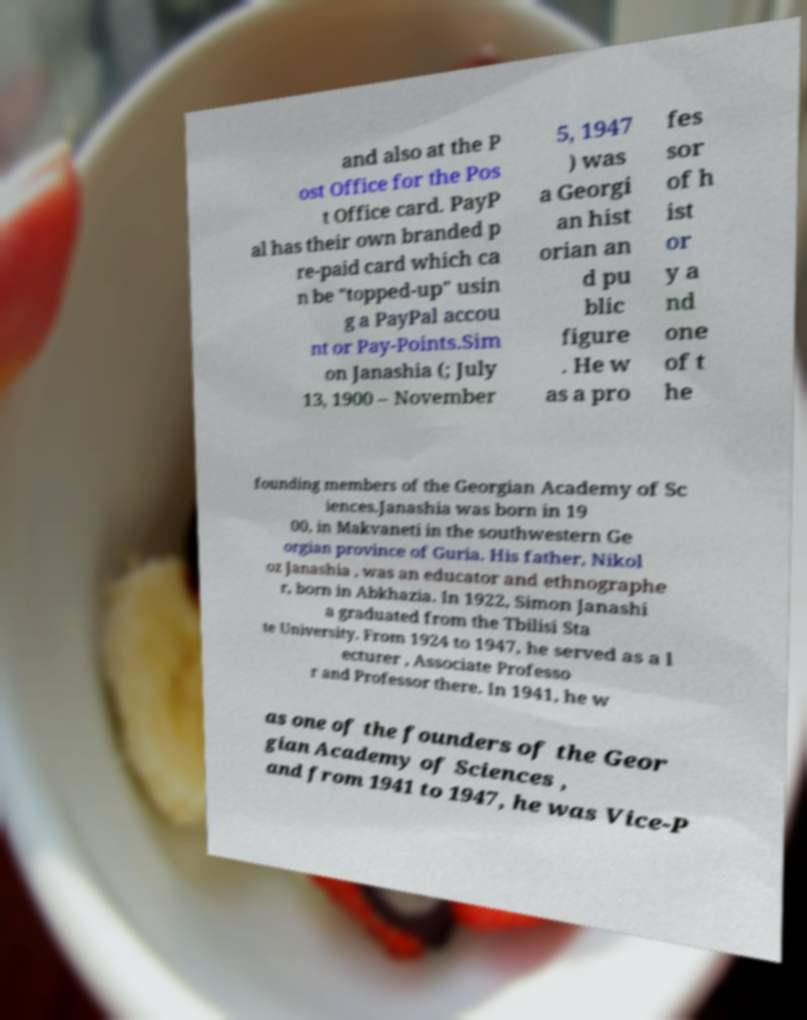What messages or text are displayed in this image? I need them in a readable, typed format. and also at the P ost Office for the Pos t Office card. PayP al has their own branded p re-paid card which ca n be "topped-up" usin g a PayPal accou nt or Pay-Points.Sim on Janashia (; July 13, 1900 – November 5, 1947 ) was a Georgi an hist orian an d pu blic figure . He w as a pro fes sor of h ist or y a nd one of t he founding members of the Georgian Academy of Sc iences.Janashia was born in 19 00, in Makvaneti in the southwestern Ge orgian province of Guria. His father, Nikol oz Janashia , was an educator and ethnographe r, born in Abkhazia. In 1922, Simon Janashi a graduated from the Tbilisi Sta te University. From 1924 to 1947, he served as a l ecturer , Associate Professo r and Professor there. In 1941, he w as one of the founders of the Geor gian Academy of Sciences , and from 1941 to 1947, he was Vice-P 